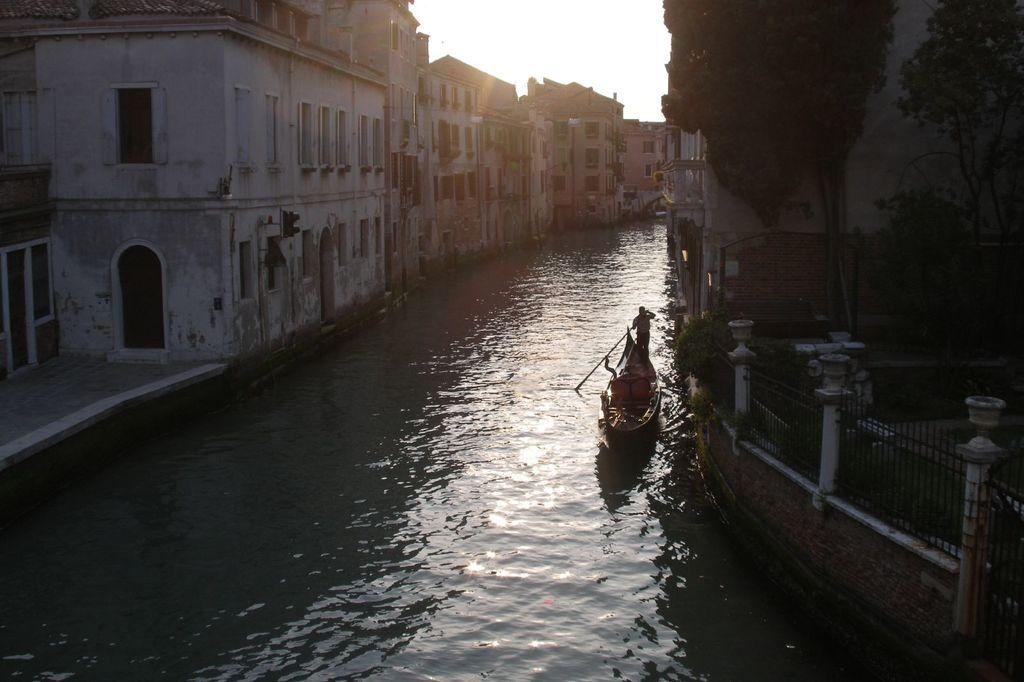What is the main subject of the image? The main subject of the image is a boat. Where is the boat located? The boat is on the water. What can be seen in the background of the image? There are buildings near the boat. What else is present in the image? There is a fence in the image. Who or what is in the boat? There is a person in the boat. What type of pin can be seen holding the boat to the pickle in the image? There is no pin or pickle present in the image; it features a boat on the water with a person and nearby buildings. 